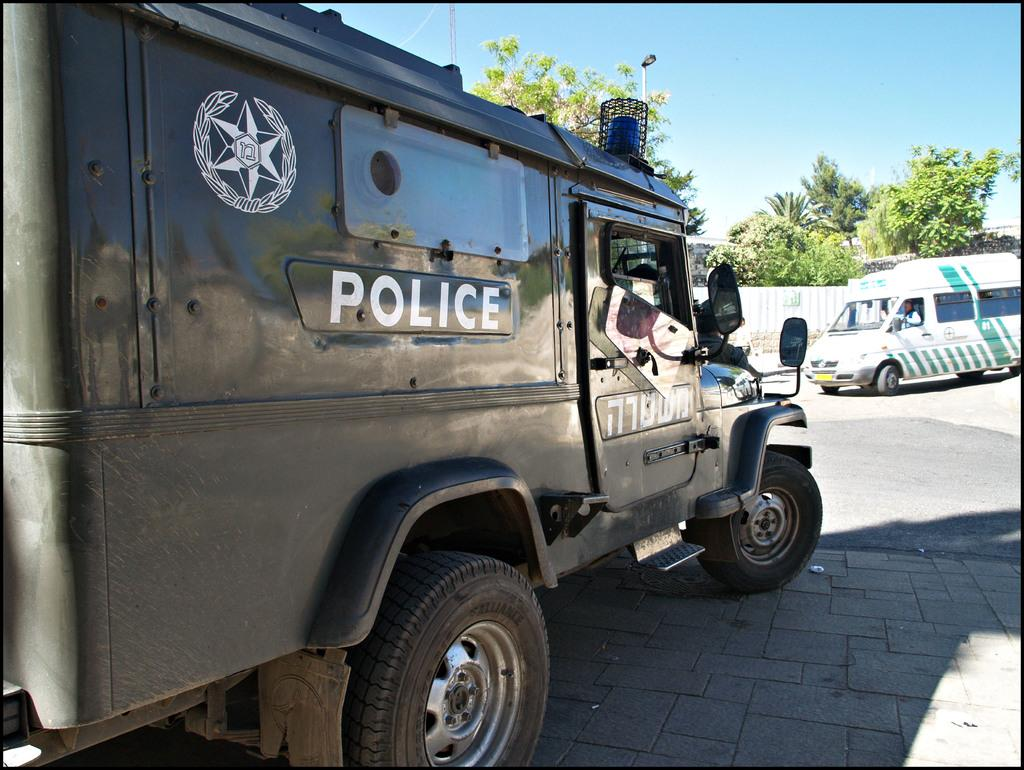What is happening on the road in the image? There are vehicles on the road in the image. Can you describe the people or objects inside the vehicles? A person is visible in one of the vehicles. What can be seen in the background of the image? There is a wall, trees, and the sky visible in the background of the image. What type of hat is the person wearing while playing a board game in the image? There is no person wearing a hat or playing a board game in the image; it features vehicles on the road with a person visible in one of them. 